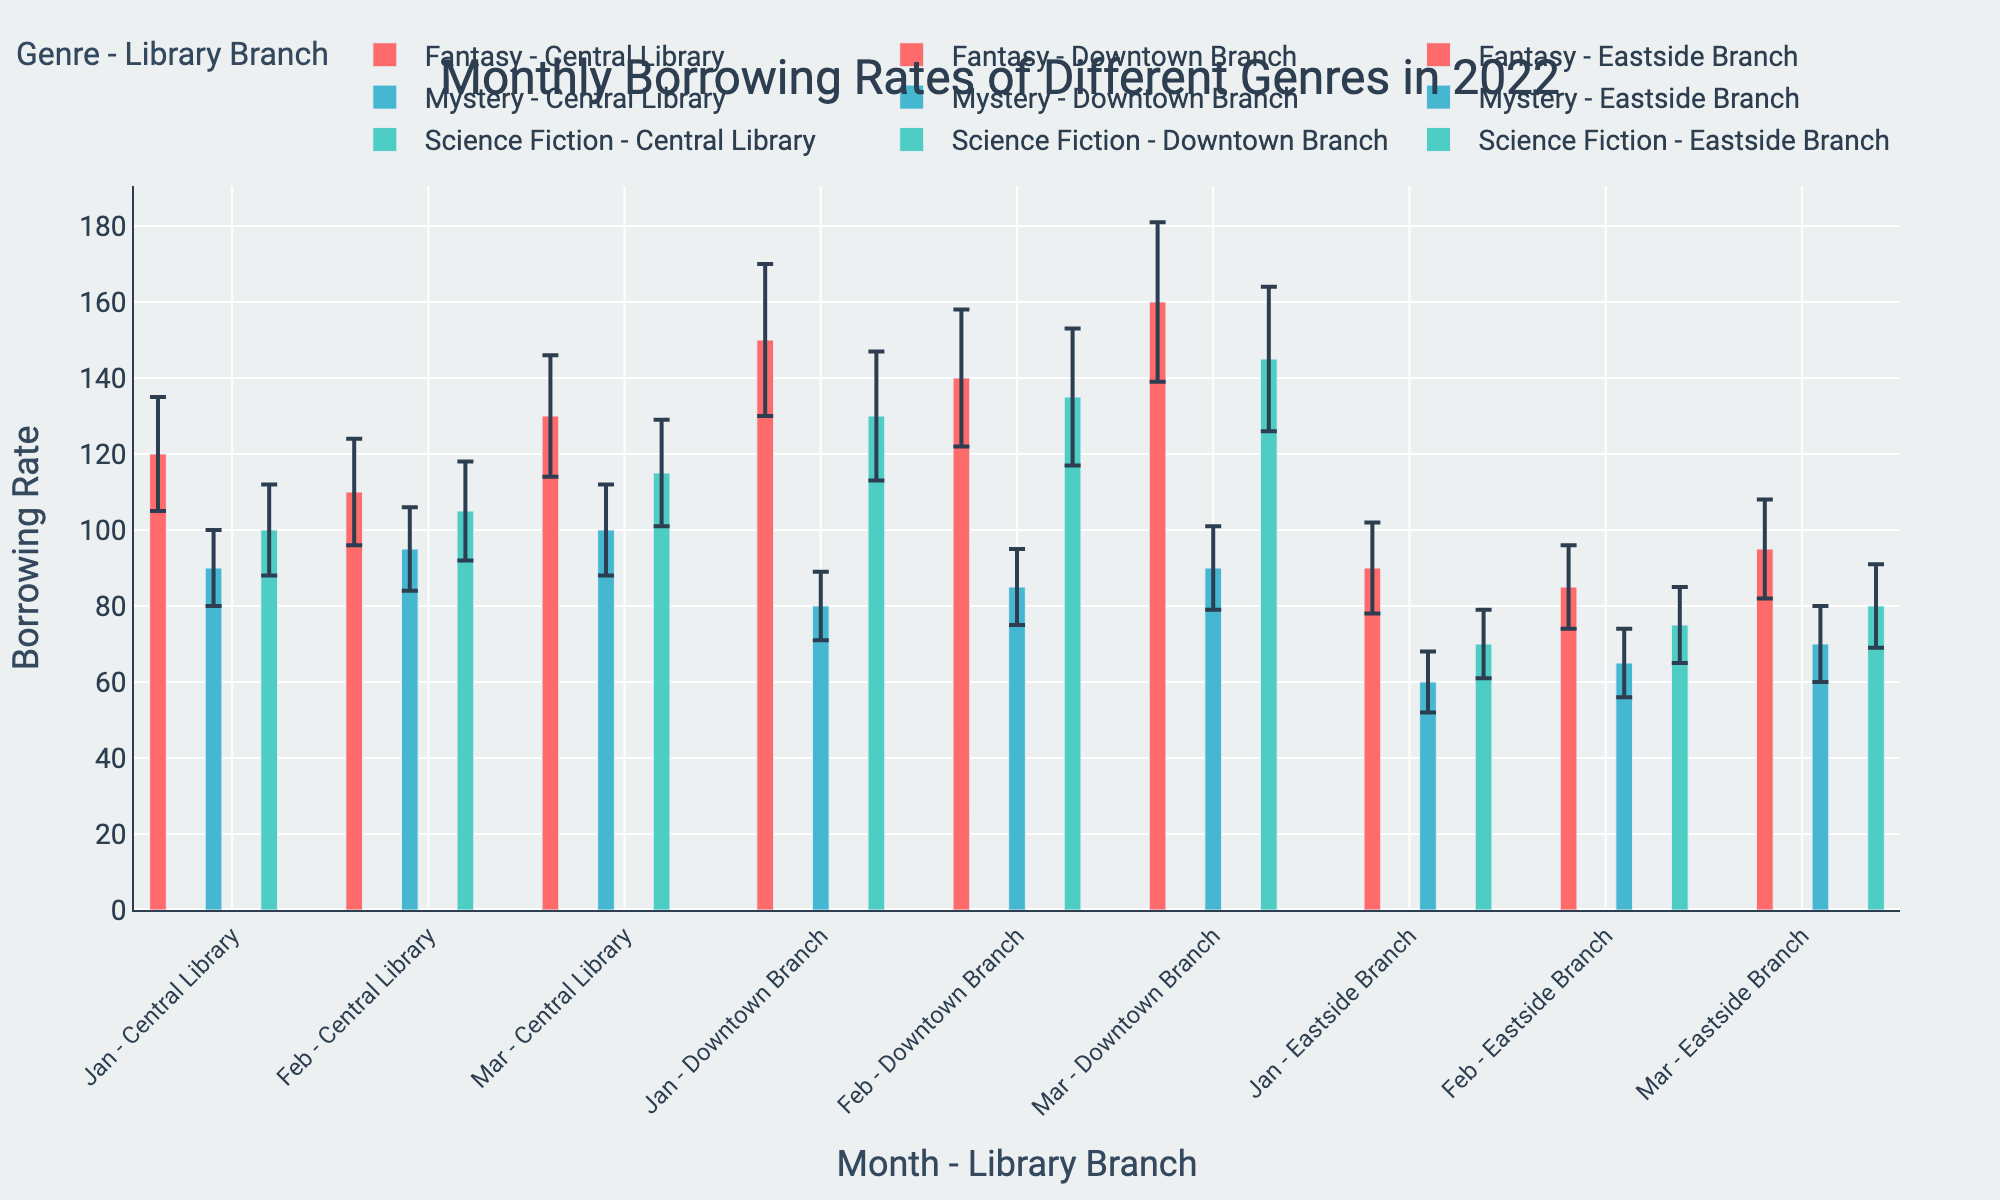What is the title of the figure? The title of the figure is usually located at the top and describes what the chart represents. Observing the title helps understand the primary focus of the chart.
Answer: Monthly Borrowing Rates of Different Genres in 2022 What is the borrowing rate for Fantasy in Feb at the Central Library? Look for the bar representing Fantasy for Feb at the Central Library and note the height of the bar.
Answer: 110 Which genre at the Downtown Branch has the lowest borrowing rate in Jan? Compare the heights of the bars at the Downtown Branch for Jan across all genres, identifying the shortest bar.
Answer: Mystery What is the combined borrowing rate of Science Fiction and Mystery at the Eastside Branch in Feb? Look at the bars for Science Fiction and Mystery at the Eastside Branch for Feb and sum up their borrowing rates.
Answer: 75 + 65 = 140 Which month had the highest borrowing rate for Fantasy at the Central Library? Compare the heights of the bars for the Fantasy genre at the Central Library across Jan, Feb, and Mar, identifying the highest bar.
Answer: Mar What is the difference in borrowing rates for Science Fiction between the Central Library and Downtown Branch in Mar? Find the borrowing rates for Science Fiction at both libraries for Mar and subtract the Central Library's rate from the Downtown Branch's rate.
Answer: 145 - 115 = 30 How many genres are represented in the chart? Count the unique colors (each representing a genre) in the legend.
Answer: 3 Which library branch has the highest borrowing rates for Fantasy in Mar? Compare the bars for Fantasy in Mar across all branches, identifying the tallest bar.
Answer: Downtown Branch What is the average borrowing rate for Mystery at the Downtonwn Branch over the three months? Sum the borrowing rates for Mystery at the Downtown Branch in Jan, Feb, and Mar, then divide by 3.
Answer: (80 + 85 + 90) / 3 = 85 Are there any genres with decreasing borrowing rates from Jan to Mar at the Central Library? Examine the bars for each genre at the Central Library from Jan to Mar, noting the trend of each.
Answer: No, all genres either increase or remain stable 